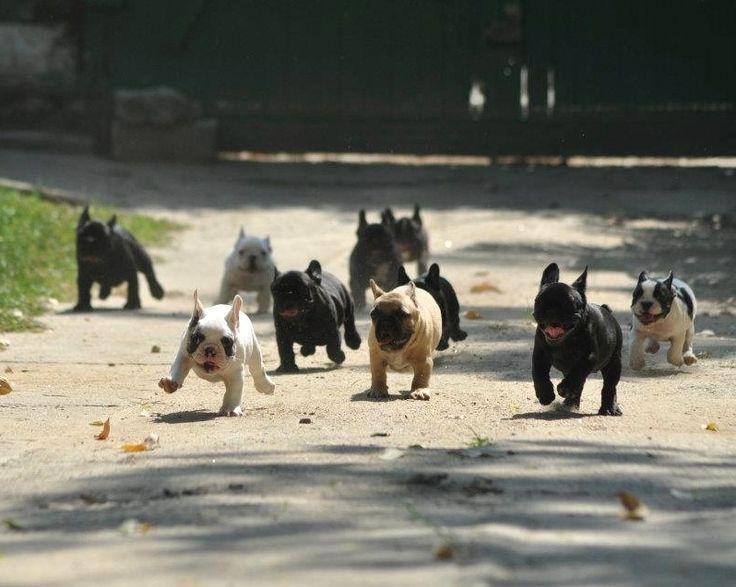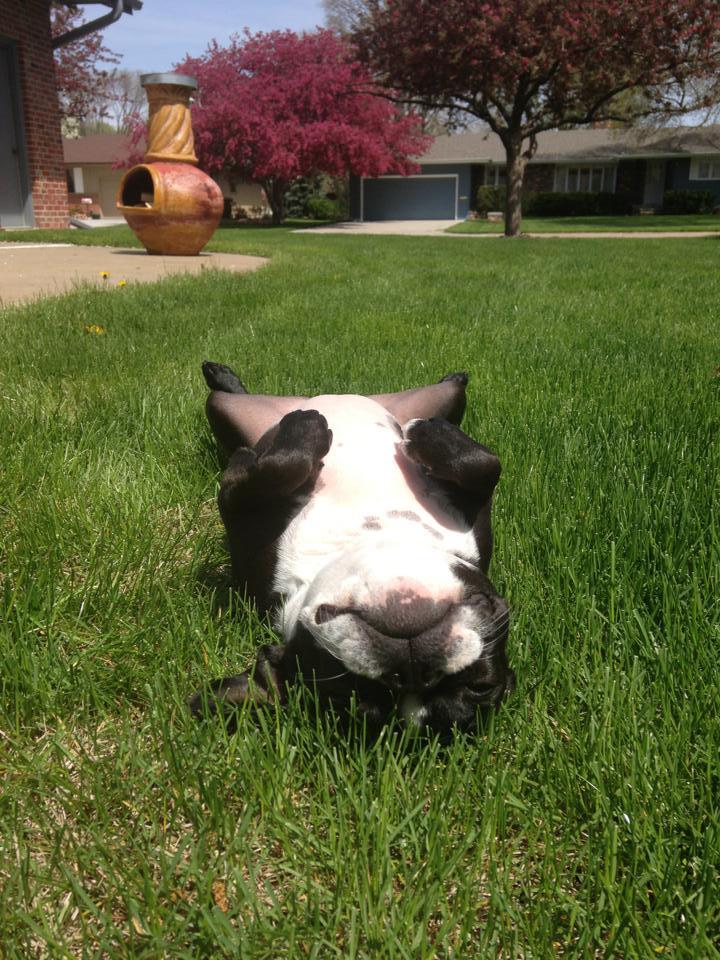The first image is the image on the left, the second image is the image on the right. Evaluate the accuracy of this statement regarding the images: "A single white and black dog is running in the sand.". Is it true? Answer yes or no. No. The first image is the image on the left, the second image is the image on the right. Assess this claim about the two images: "The right image shows a black and white french bulldog puppy running on sand". Correct or not? Answer yes or no. No. 